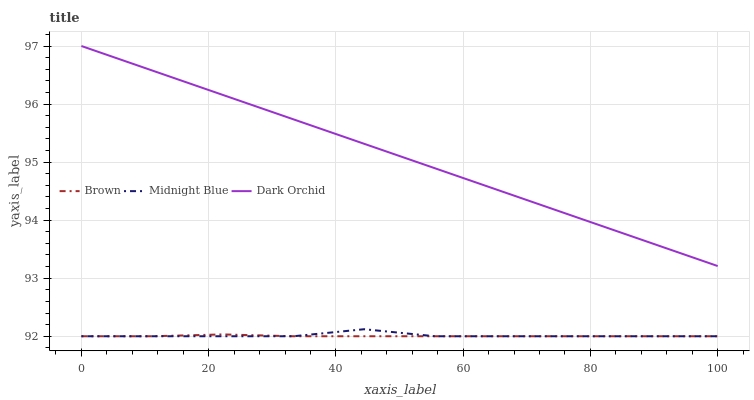Does Brown have the minimum area under the curve?
Answer yes or no. Yes. Does Dark Orchid have the maximum area under the curve?
Answer yes or no. Yes. Does Midnight Blue have the minimum area under the curve?
Answer yes or no. No. Does Midnight Blue have the maximum area under the curve?
Answer yes or no. No. Is Dark Orchid the smoothest?
Answer yes or no. Yes. Is Midnight Blue the roughest?
Answer yes or no. Yes. Is Midnight Blue the smoothest?
Answer yes or no. No. Is Dark Orchid the roughest?
Answer yes or no. No. Does Brown have the lowest value?
Answer yes or no. Yes. Does Dark Orchid have the lowest value?
Answer yes or no. No. Does Dark Orchid have the highest value?
Answer yes or no. Yes. Does Midnight Blue have the highest value?
Answer yes or no. No. Is Midnight Blue less than Dark Orchid?
Answer yes or no. Yes. Is Dark Orchid greater than Brown?
Answer yes or no. Yes. Does Brown intersect Midnight Blue?
Answer yes or no. Yes. Is Brown less than Midnight Blue?
Answer yes or no. No. Is Brown greater than Midnight Blue?
Answer yes or no. No. Does Midnight Blue intersect Dark Orchid?
Answer yes or no. No. 